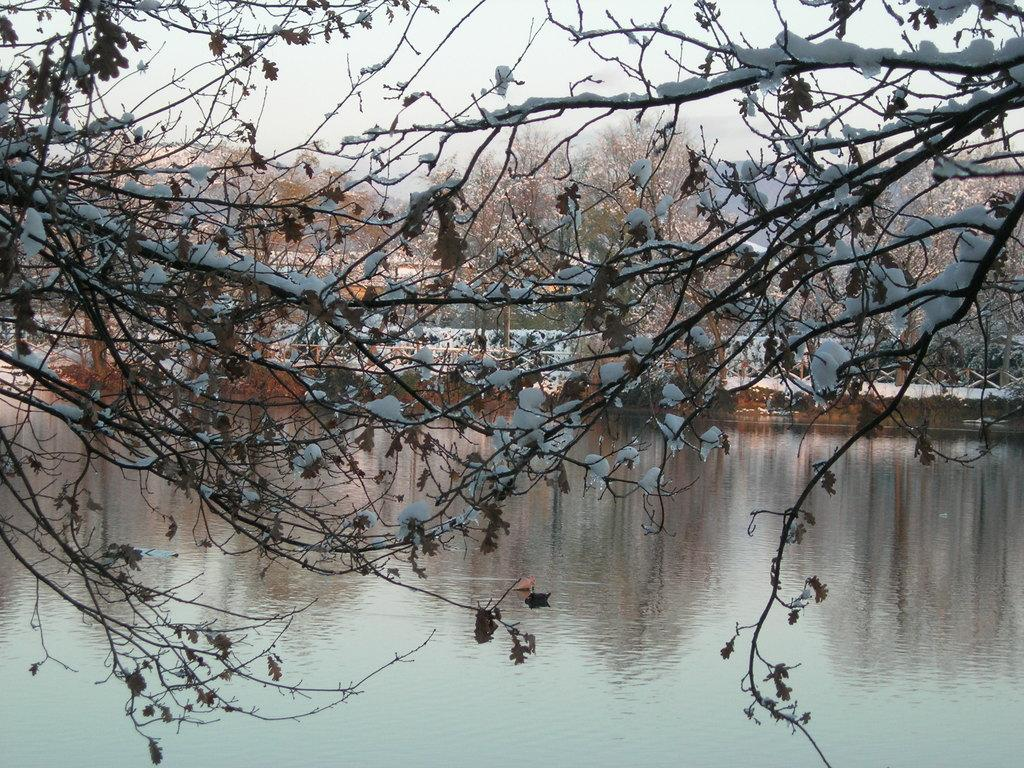What is located in the center of the image? There are trees in the center of the image. What is at the bottom of the image? There is a lake at the bottom of the image. What can be seen in the background of the image? The sky is visible in the background of the image. How many insects can be seen gripping the side of the trees in the image? There are no insects visible in the image, and therefore no insects can be seen gripping the side of the trees. 